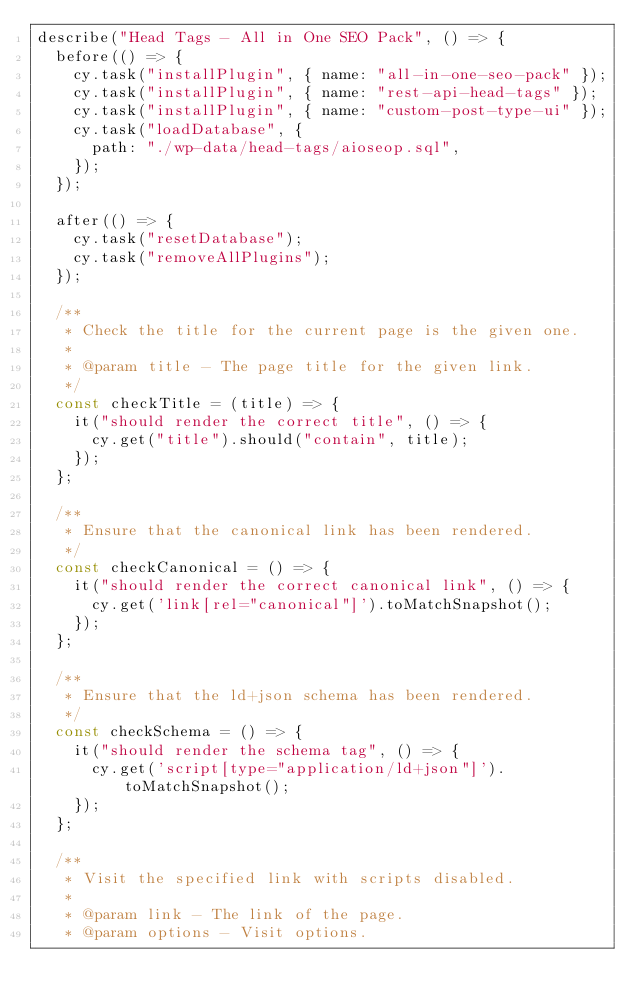Convert code to text. <code><loc_0><loc_0><loc_500><loc_500><_JavaScript_>describe("Head Tags - All in One SEO Pack", () => {
  before(() => {
    cy.task("installPlugin", { name: "all-in-one-seo-pack" });
    cy.task("installPlugin", { name: "rest-api-head-tags" });
    cy.task("installPlugin", { name: "custom-post-type-ui" });
    cy.task("loadDatabase", {
      path: "./wp-data/head-tags/aioseop.sql",
    });
  });

  after(() => {
    cy.task("resetDatabase");
    cy.task("removeAllPlugins");
  });

  /**
   * Check the title for the current page is the given one.
   *
   * @param title - The page title for the given link.
   */
  const checkTitle = (title) => {
    it("should render the correct title", () => {
      cy.get("title").should("contain", title);
    });
  };

  /**
   * Ensure that the canonical link has been rendered.
   */
  const checkCanonical = () => {
    it("should render the correct canonical link", () => {
      cy.get('link[rel="canonical"]').toMatchSnapshot();
    });
  };

  /**
   * Ensure that the ld+json schema has been rendered.
   */
  const checkSchema = () => {
    it("should render the schema tag", () => {
      cy.get('script[type="application/ld+json"]').toMatchSnapshot();
    });
  };

  /**
   * Visit the specified link with scripts disabled.
   *
   * @param link - The link of the page.
   * @param options - Visit options.</code> 